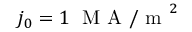Convert formula to latex. <formula><loc_0><loc_0><loc_500><loc_500>j _ { 0 } = 1 \, M A / m ^ { 2 }</formula> 